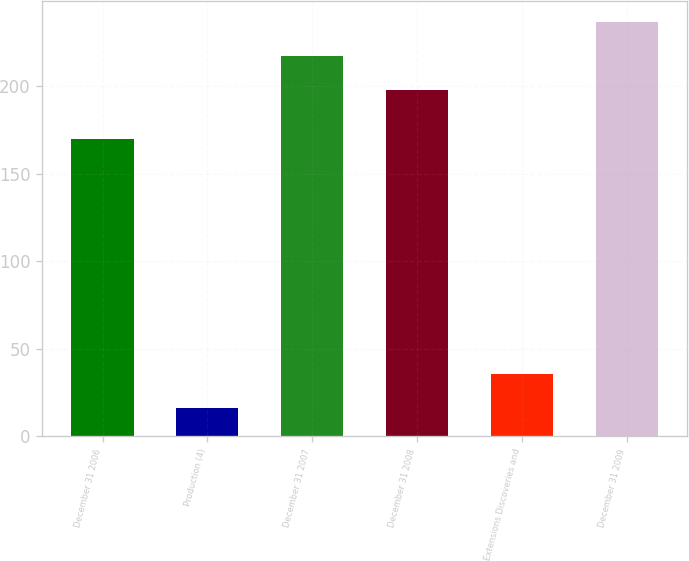Convert chart. <chart><loc_0><loc_0><loc_500><loc_500><bar_chart><fcel>December 31 2006<fcel>Production (4)<fcel>December 31 2007<fcel>December 31 2008<fcel>Extensions Discoveries and<fcel>December 31 2009<nl><fcel>170<fcel>16<fcel>217.3<fcel>198<fcel>35.3<fcel>236.6<nl></chart> 